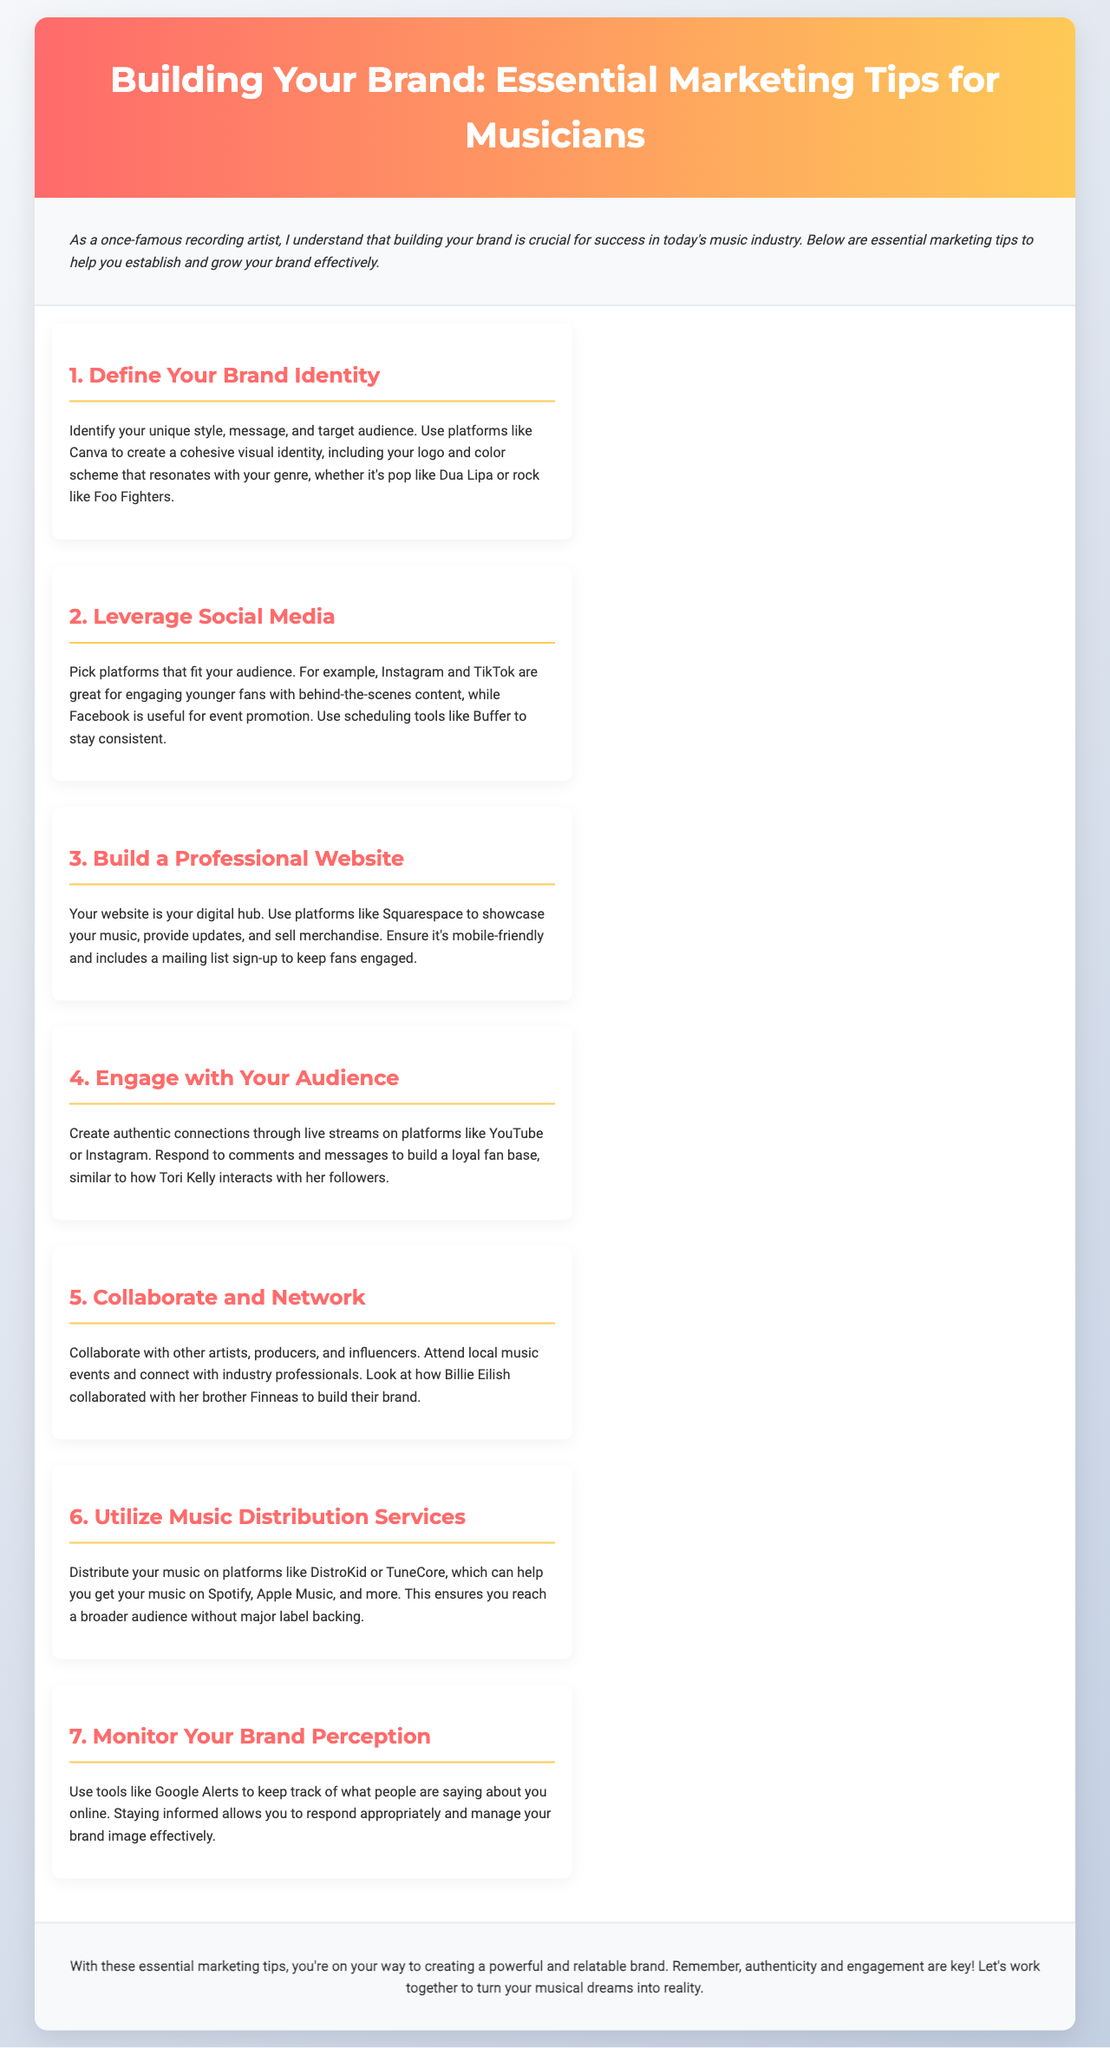What is the title of the brochure? The title is mentioned prominently at the top of the document.
Answer: Building Your Brand: Essential Marketing Tips for Musicians Who shares their insights in the brochure? The introduction mentions who is providing the tips.
Answer: A once-famous recording artist What is the first marketing tip listed? The first tip is clearly outlined in a dedicated section.
Answer: Define Your Brand Identity Which social media platforms are suggested for engaging younger fans? The second tip includes examples of platforms for specific audiences.
Answer: Instagram and TikTok What service is recommended for music distribution? The sixth tip specifies services to distribute music.
Answer: DistroKid or TuneCore What is the purpose of building a professional website? The third tip elaborates on what a professional website should achieve.
Answer: Digital hub What should you do to monitor your brand perception? The seventh tip provides a specific tool for tracking brand mentions.
Answer: Google Alerts How should you interact with your audience according to the brochure? The fourth tip explains how to create connections with the audience.
Answer: Live streams What are two elements considered key for a powerful brand? The closing section emphasizes important characteristics of branding.
Answer: Authenticity and engagement 